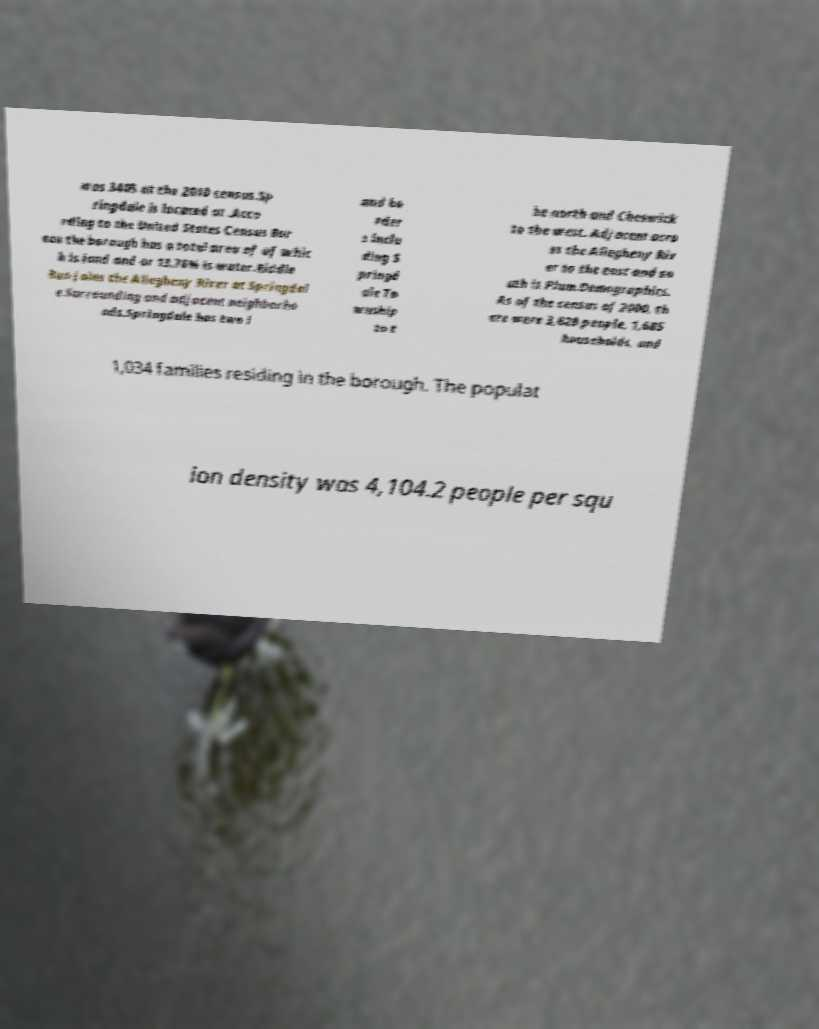What messages or text are displayed in this image? I need them in a readable, typed format. was 3405 at the 2010 census.Sp ringdale is located at .Acco rding to the United States Census Bur eau the borough has a total area of of whic h is land and or 13.76% is water.Riddle Run joins the Allegheny River at Springdal e.Surrounding and adjacent neighborho ods.Springdale has two l and bo rder s inclu ding S pringd ale To wnship to t he north and Cheswick to the west. Adjacent acro ss the Allegheny Riv er to the east and so uth is Plum.Demographics. As of the census of 2000, th ere were 3,828 people, 1,685 households, and 1,034 families residing in the borough. The populat ion density was 4,104.2 people per squ 